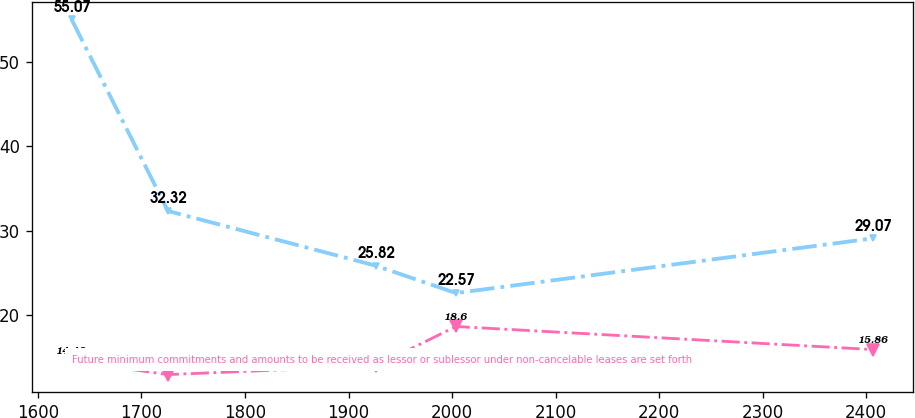Convert chart to OTSL. <chart><loc_0><loc_0><loc_500><loc_500><line_chart><ecel><fcel>Unnamed: 1<fcel>Future minimum commitments and amounts to be received as lessor or sublessor under non-cancelable leases are set forth<nl><fcel>1632.53<fcel>55.07<fcel>14.48<nl><fcel>1725.57<fcel>32.32<fcel>12.89<nl><fcel>1926.33<fcel>25.82<fcel>13.91<nl><fcel>2003.75<fcel>22.57<fcel>18.6<nl><fcel>2406.75<fcel>29.07<fcel>15.86<nl></chart> 